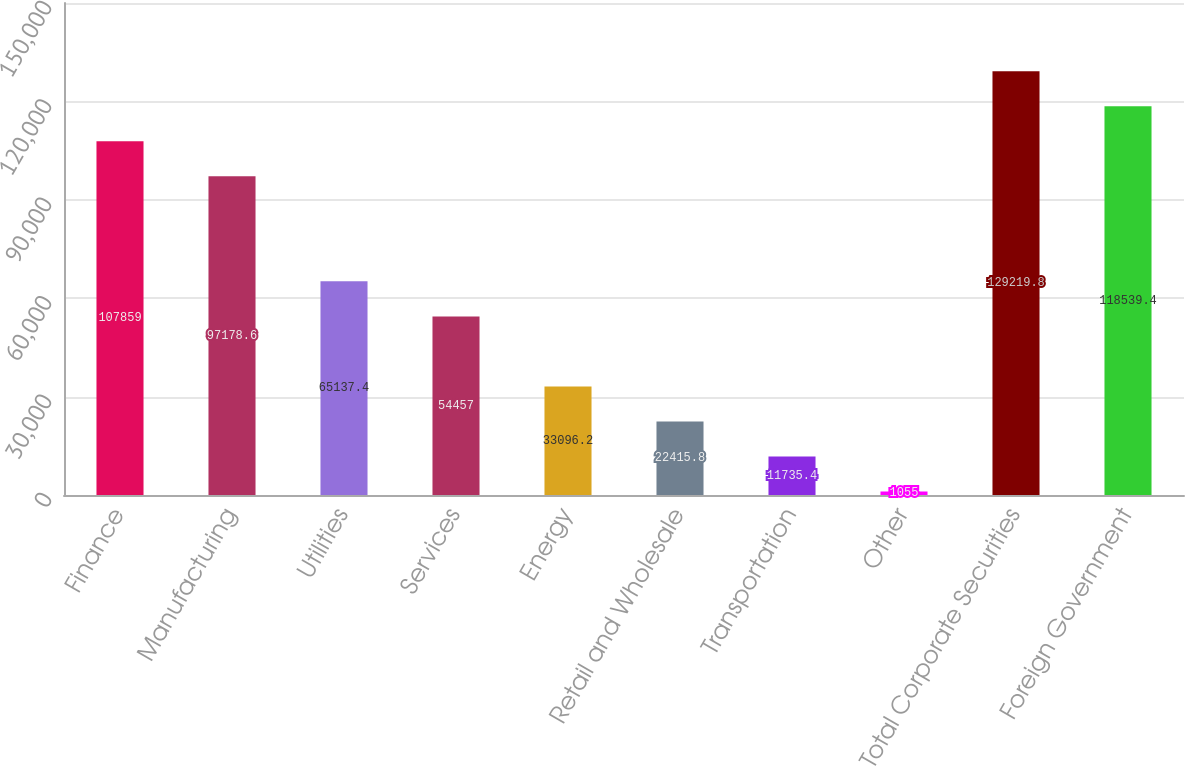Convert chart. <chart><loc_0><loc_0><loc_500><loc_500><bar_chart><fcel>Finance<fcel>Manufacturing<fcel>Utilities<fcel>Services<fcel>Energy<fcel>Retail and Wholesale<fcel>Transportation<fcel>Other<fcel>Total Corporate Securities<fcel>Foreign Government<nl><fcel>107859<fcel>97178.6<fcel>65137.4<fcel>54457<fcel>33096.2<fcel>22415.8<fcel>11735.4<fcel>1055<fcel>129220<fcel>118539<nl></chart> 